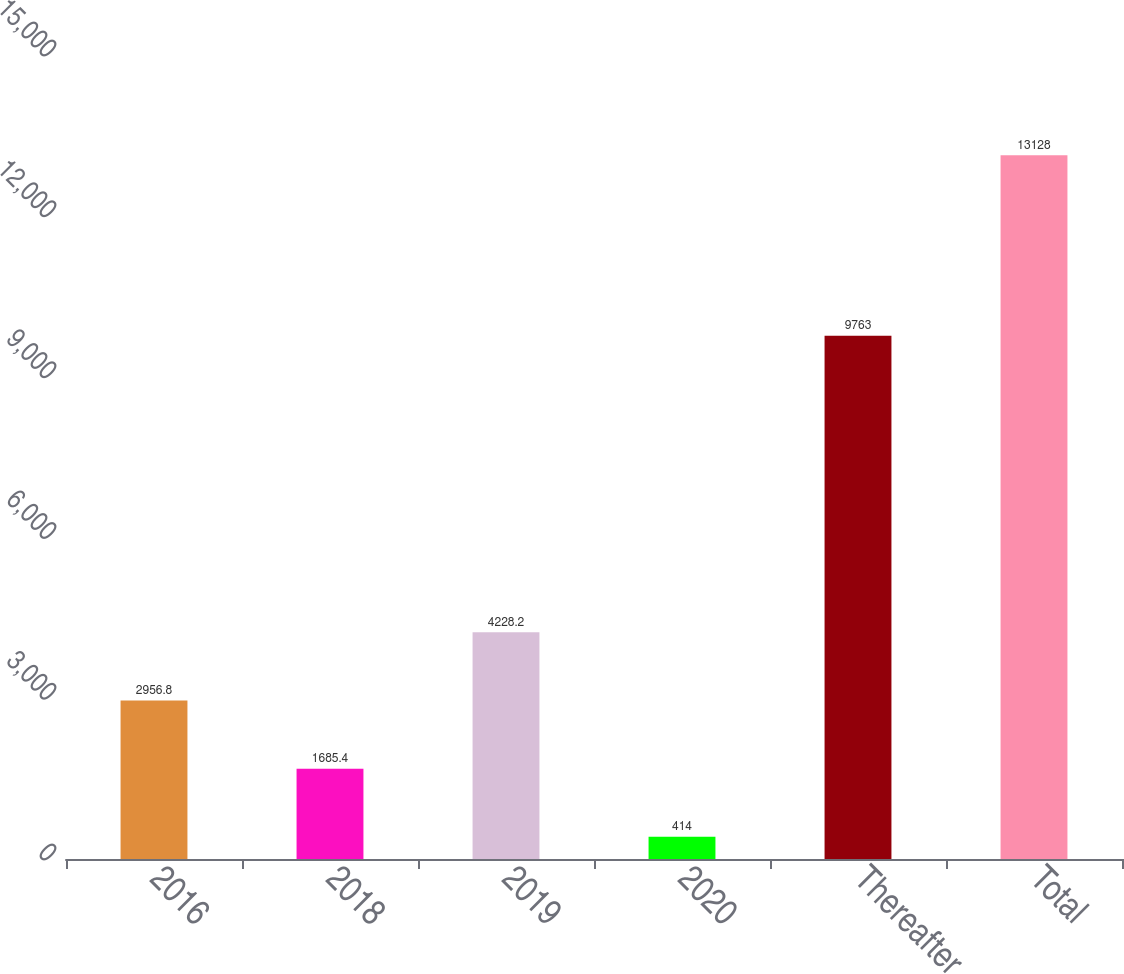<chart> <loc_0><loc_0><loc_500><loc_500><bar_chart><fcel>2016<fcel>2018<fcel>2019<fcel>2020<fcel>Thereafter<fcel>Total<nl><fcel>2956.8<fcel>1685.4<fcel>4228.2<fcel>414<fcel>9763<fcel>13128<nl></chart> 